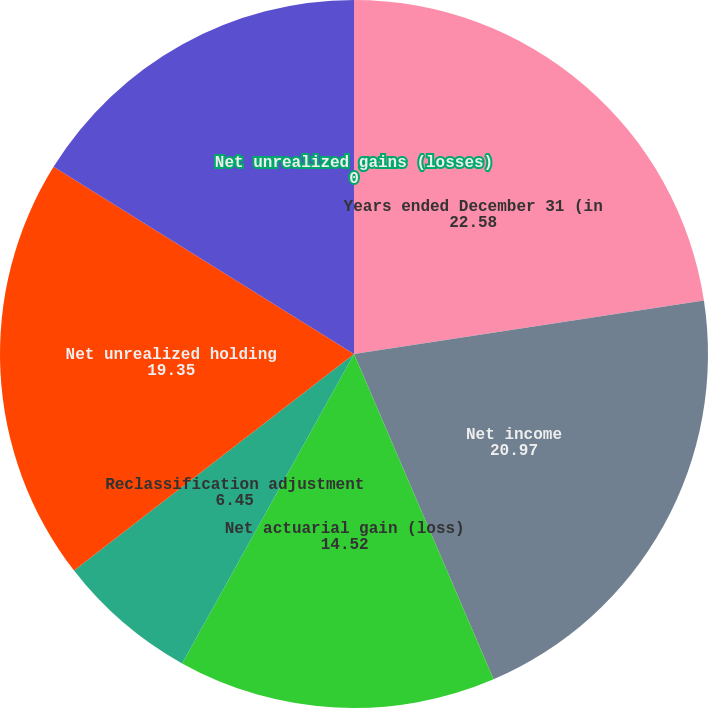Convert chart. <chart><loc_0><loc_0><loc_500><loc_500><pie_chart><fcel>Years ended December 31 (in<fcel>Net income<fcel>Net actuarial gain (loss)<fcel>Reclassification adjustment<fcel>Net unrealized holding<fcel>Net unrealized (losses) gains<fcel>Net unrealized gains (losses)<nl><fcel>22.58%<fcel>20.97%<fcel>14.52%<fcel>6.45%<fcel>19.35%<fcel>16.13%<fcel>0.0%<nl></chart> 